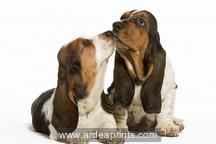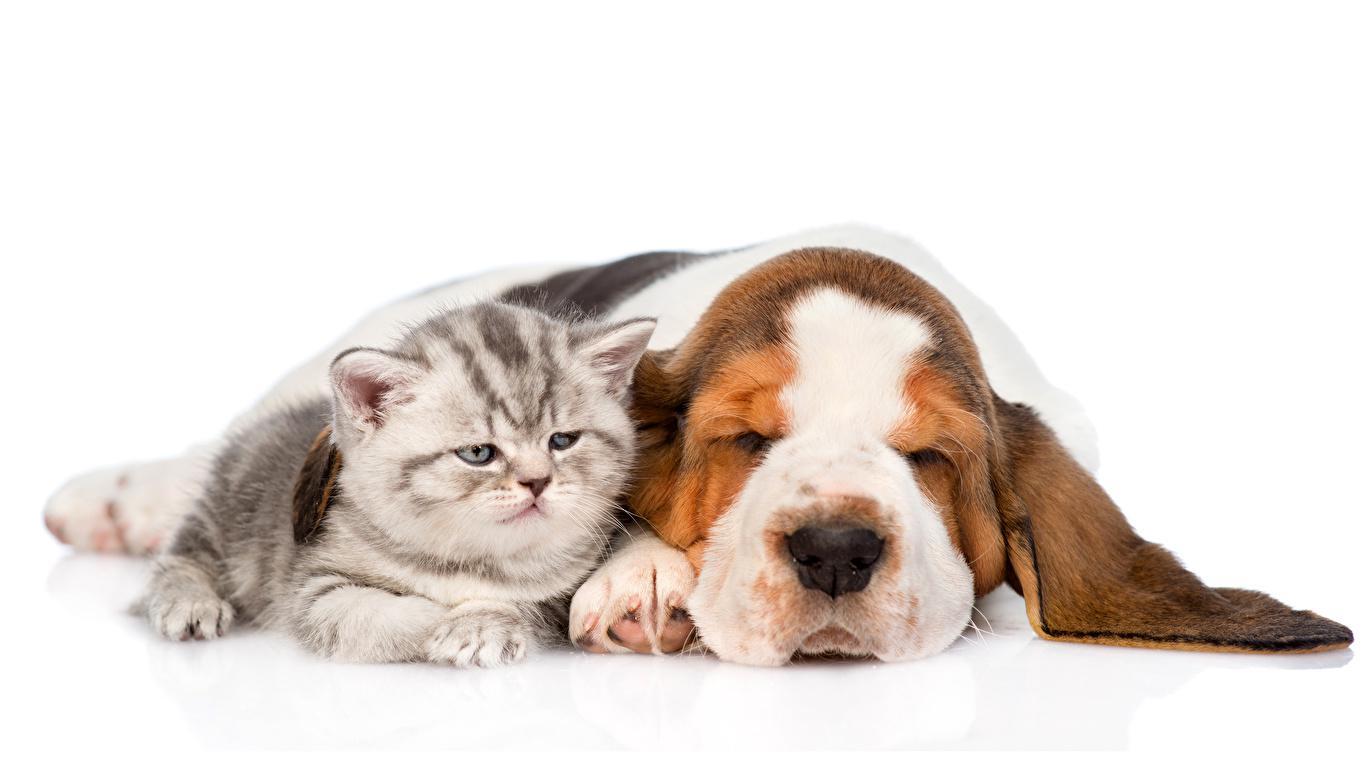The first image is the image on the left, the second image is the image on the right. Considering the images on both sides, is "Two dogs with brown and white coloring are in each image, sitting side by side, with the head of one higher, and front paws forward and flat." valid? Answer yes or no. No. The first image is the image on the left, the second image is the image on the right. Given the left and right images, does the statement "An image shows a long-eared basset hound posed next to another type of pet." hold true? Answer yes or no. Yes. 